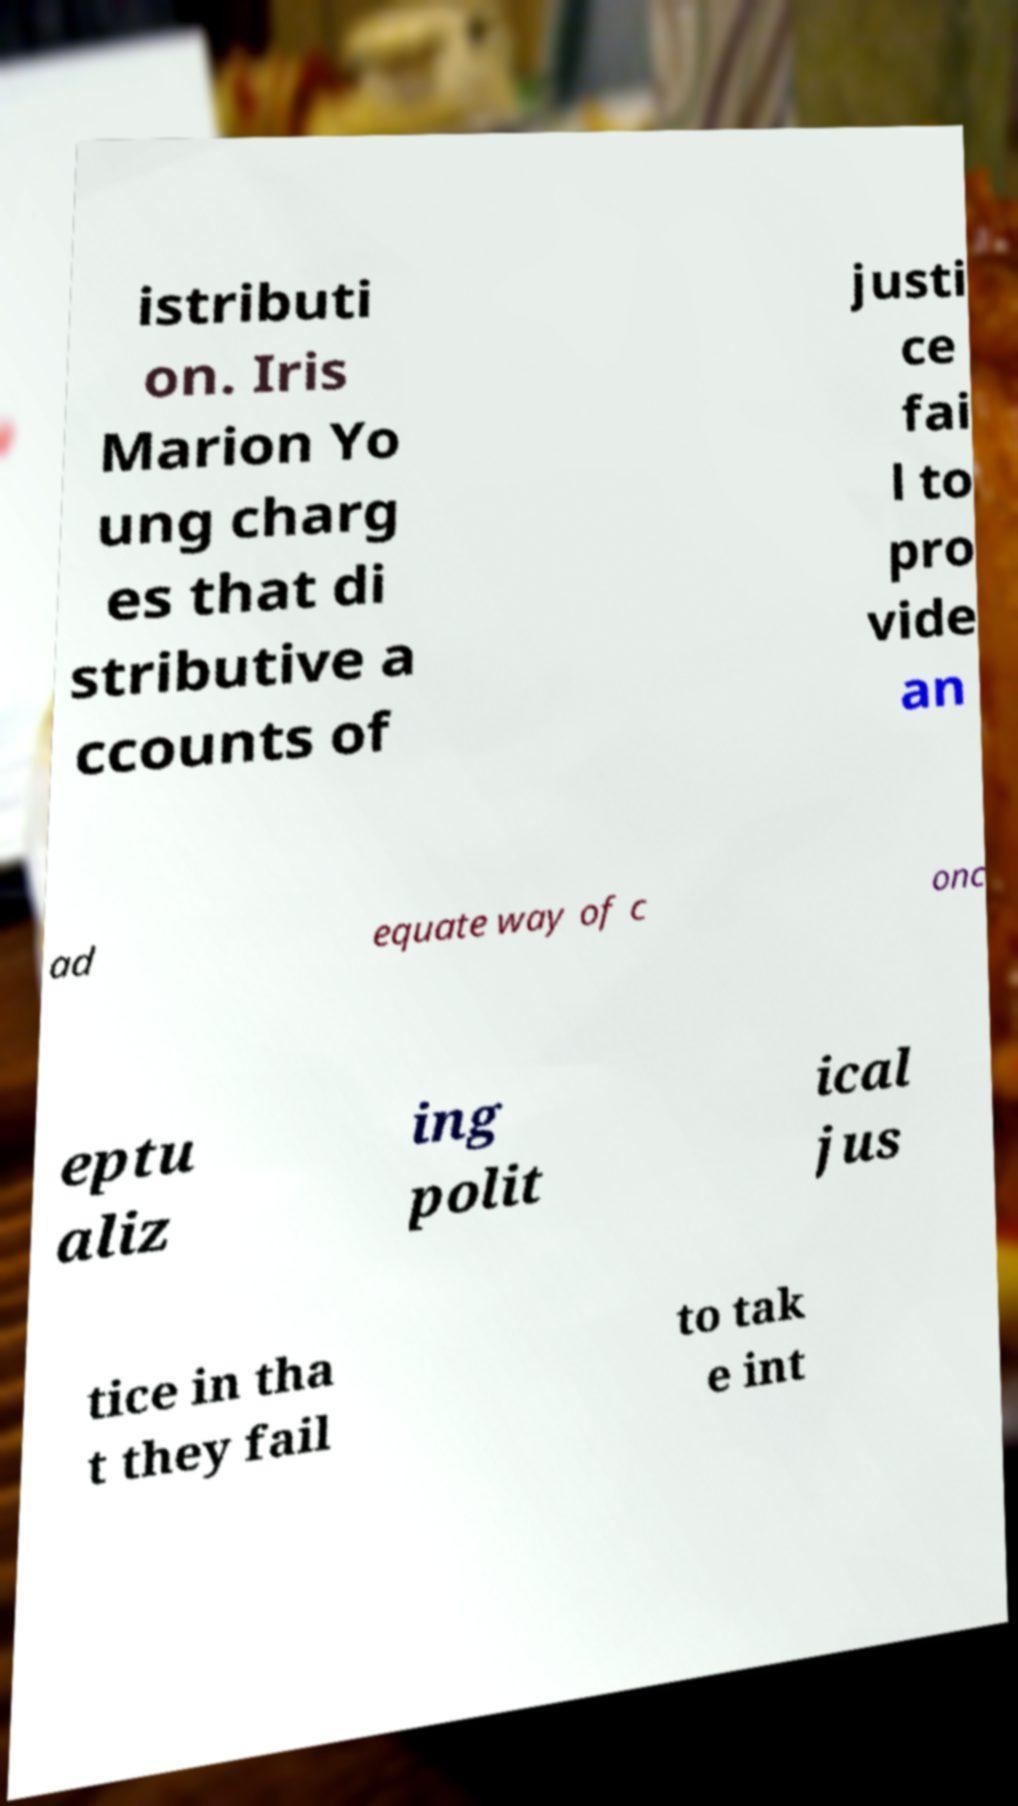Please identify and transcribe the text found in this image. istributi on. Iris Marion Yo ung charg es that di stributive a ccounts of justi ce fai l to pro vide an ad equate way of c onc eptu aliz ing polit ical jus tice in tha t they fail to tak e int 